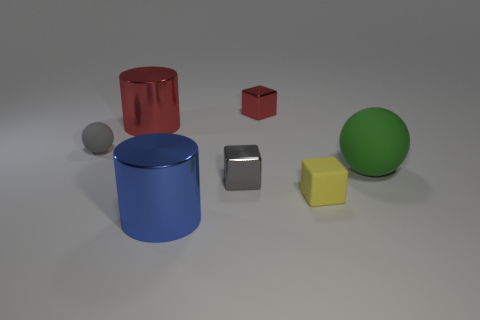Subtract all green balls. Subtract all yellow cylinders. How many balls are left? 1 Add 2 gray rubber things. How many objects exist? 9 Subtract all cylinders. How many objects are left? 5 Subtract all small gray matte balls. Subtract all red metallic objects. How many objects are left? 4 Add 4 cylinders. How many cylinders are left? 6 Add 2 gray rubber things. How many gray rubber things exist? 3 Subtract 0 yellow balls. How many objects are left? 7 